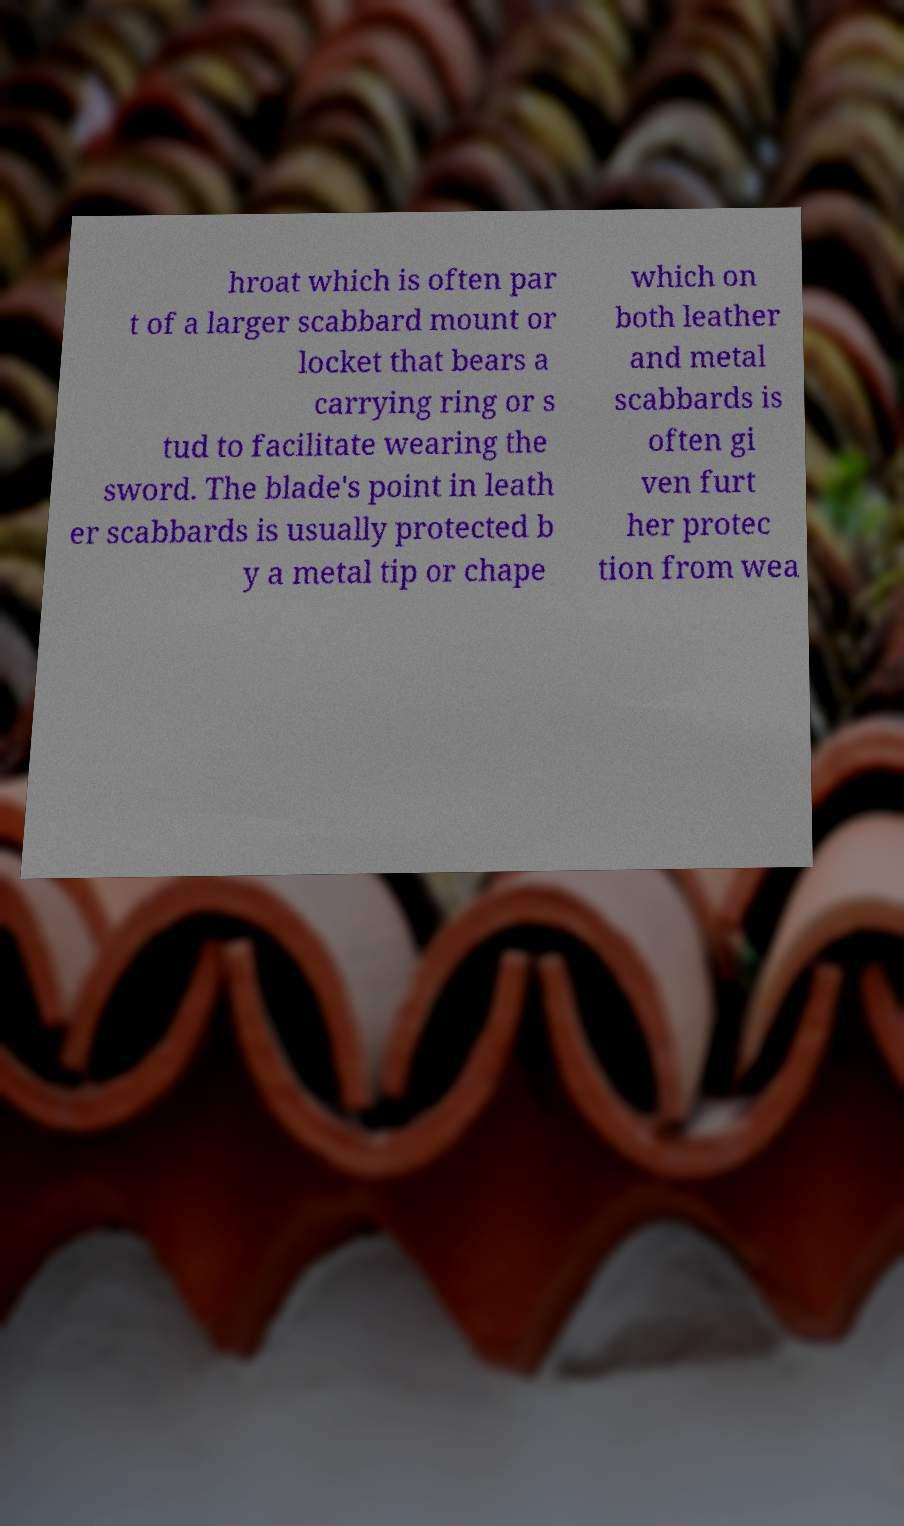I need the written content from this picture converted into text. Can you do that? hroat which is often par t of a larger scabbard mount or locket that bears a carrying ring or s tud to facilitate wearing the sword. The blade's point in leath er scabbards is usually protected b y a metal tip or chape which on both leather and metal scabbards is often gi ven furt her protec tion from wea 